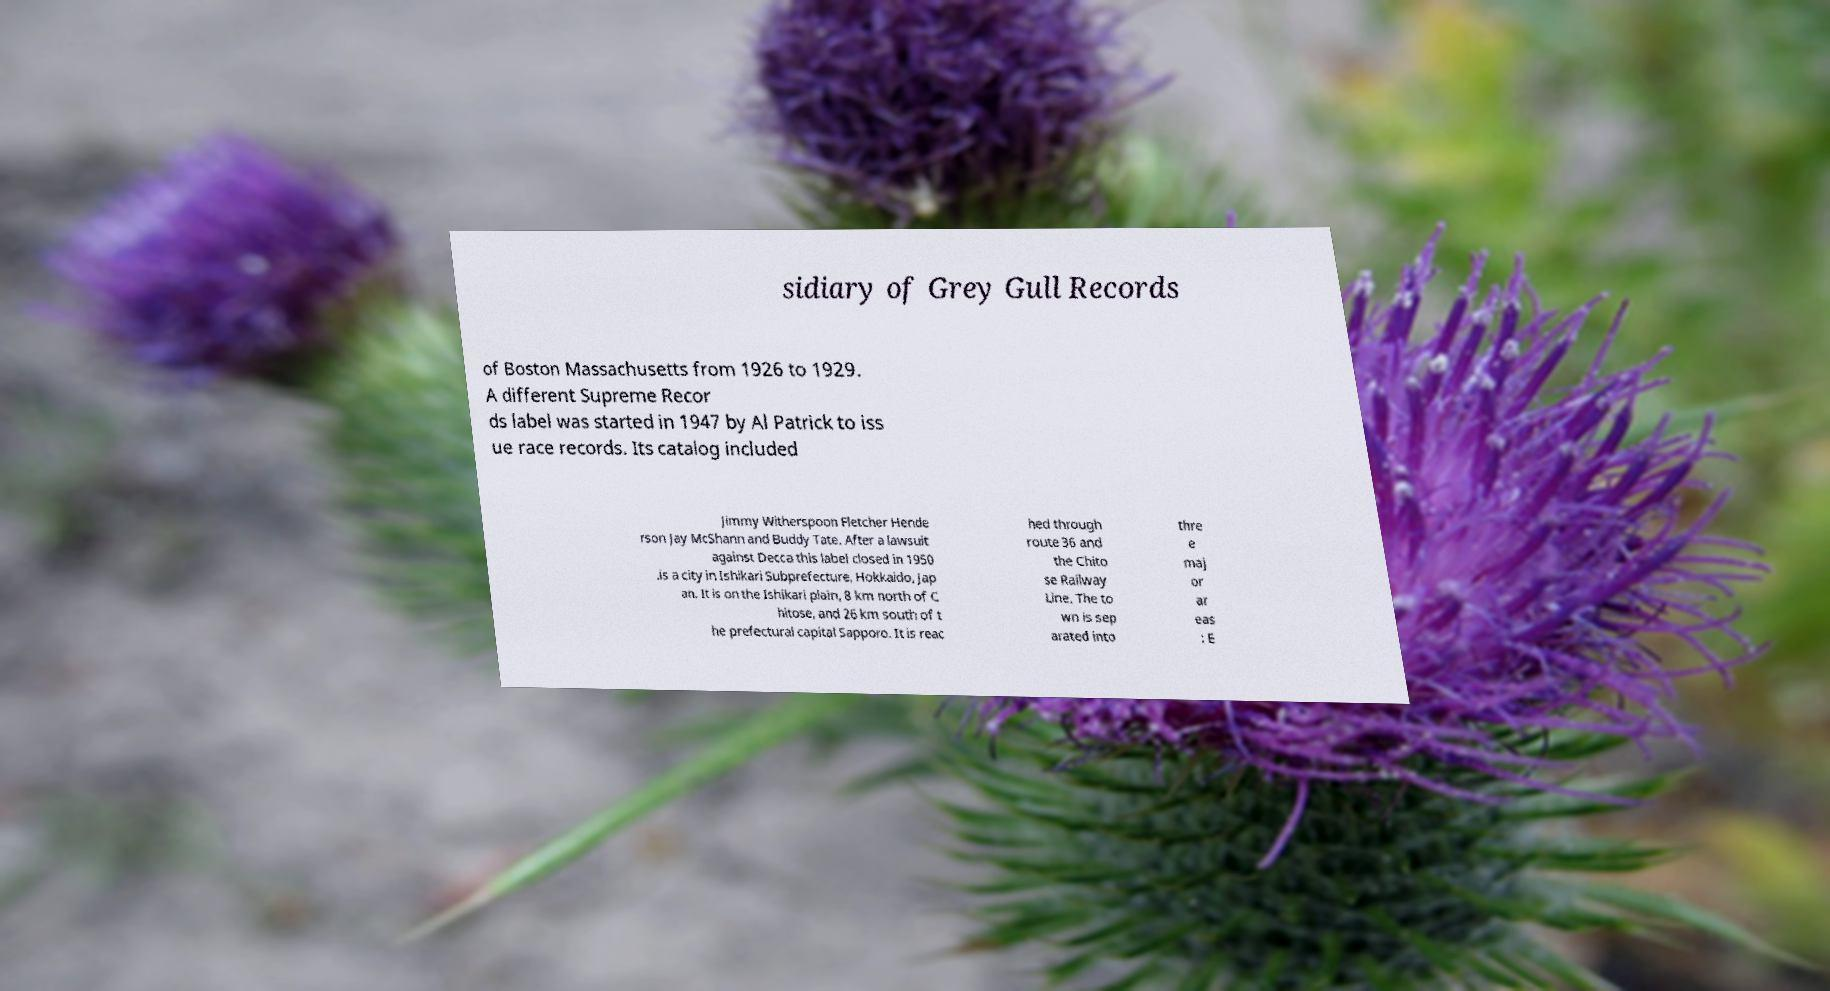Could you extract and type out the text from this image? sidiary of Grey Gull Records of Boston Massachusetts from 1926 to 1929. A different Supreme Recor ds label was started in 1947 by Al Patrick to iss ue race records. Its catalog included Jimmy Witherspoon Fletcher Hende rson Jay McShann and Buddy Tate. After a lawsuit against Decca this label closed in 1950 .is a city in Ishikari Subprefecture, Hokkaido, Jap an. It is on the Ishikari plain, 8 km north of C hitose, and 26 km south of t he prefectural capital Sapporo. It is reac hed through route 36 and the Chito se Railway Line. The to wn is sep arated into thre e maj or ar eas : E 